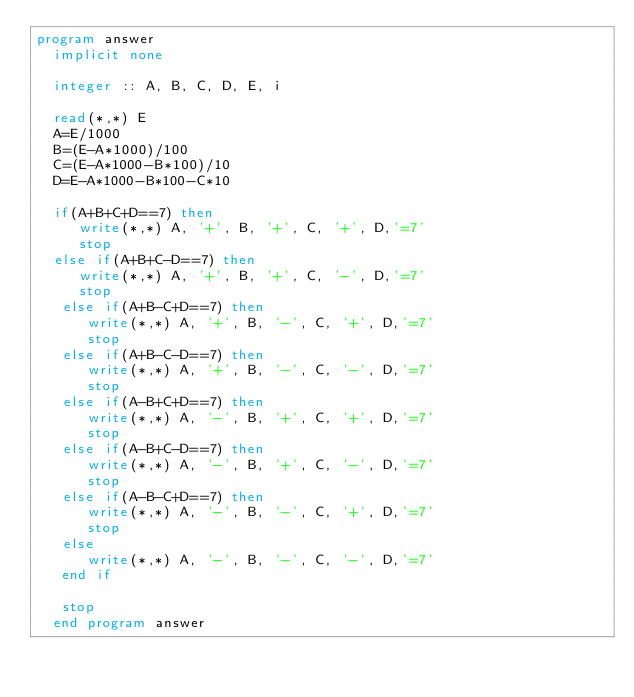<code> <loc_0><loc_0><loc_500><loc_500><_FORTRAN_>program answer
  implicit none

  integer :: A, B, C, D, E, i

  read(*,*) E
  A=E/1000
  B=(E-A*1000)/100
  C=(E-A*1000-B*100)/10
  D=E-A*1000-B*100-C*10

  if(A+B+C+D==7) then
     write(*,*) A, '+', B, '+', C, '+', D,'=7'
     stop
  else if(A+B+C-D==7) then
     write(*,*) A, '+', B, '+', C, '-', D,'=7'
     stop
   else if(A+B-C+D==7) then
      write(*,*) A, '+', B, '-', C, '+', D,'=7'
      stop
   else if(A+B-C-D==7) then
      write(*,*) A, '+', B, '-', C, '-', D,'=7'
      stop
   else if(A-B+C+D==7) then
      write(*,*) A, '-', B, '+', C, '+', D,'=7'
      stop
   else if(A-B+C-D==7) then
      write(*,*) A, '-', B, '+', C, '-', D,'=7'
      stop
   else if(A-B-C+D==7) then
      write(*,*) A, '-', B, '-', C, '+', D,'=7'
      stop
   else
      write(*,*) A, '-', B, '-', C, '-', D,'=7'
   end if

   stop
  end program answer
</code> 